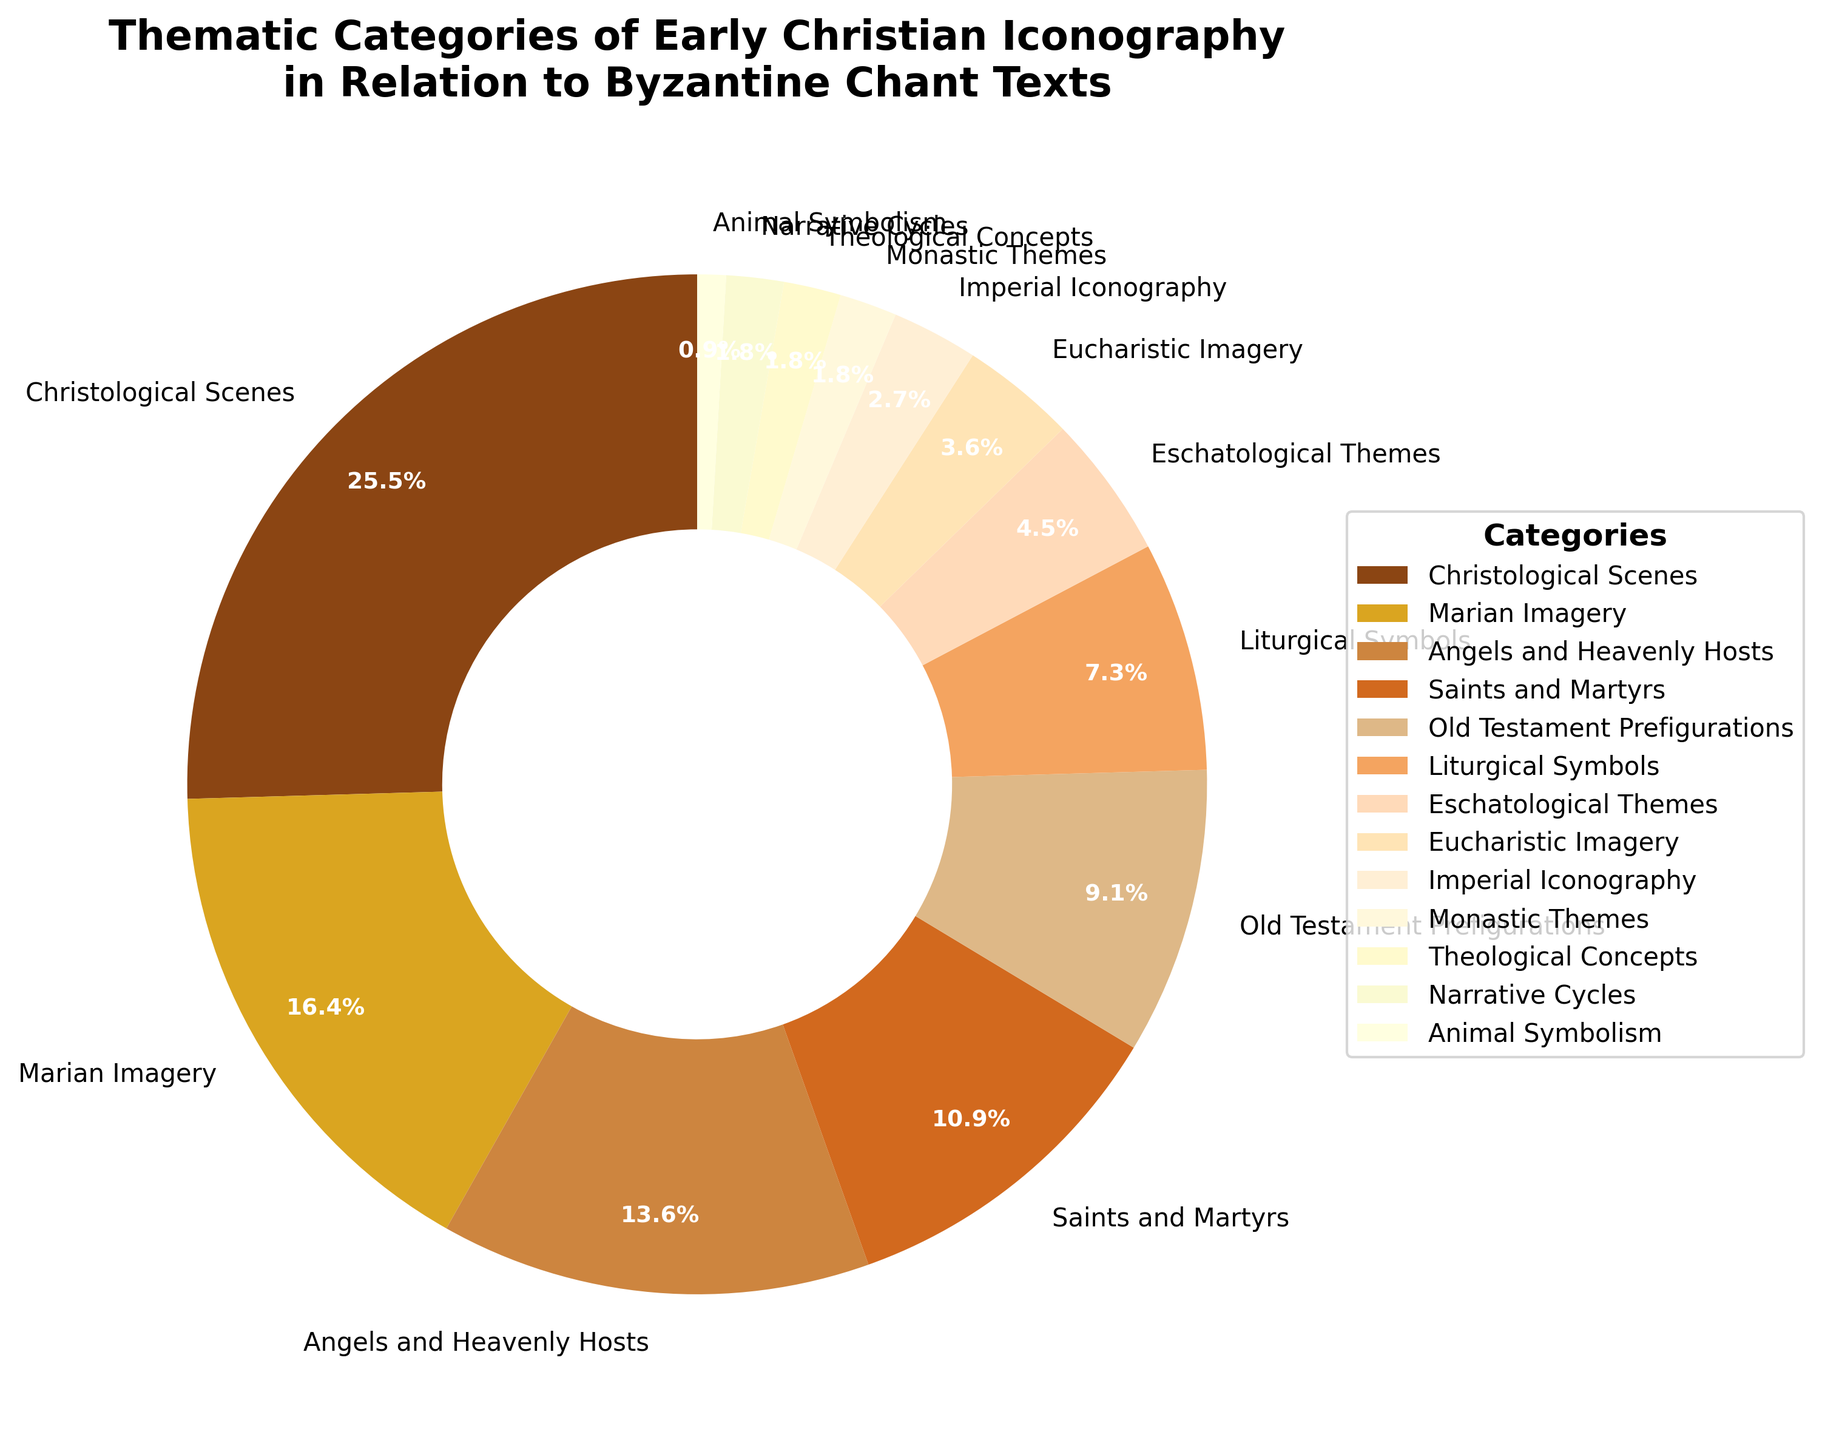What's the combined percentage of "Eschatological Themes" and "Eucharistic Imagery"? First, identify the percentage of "Eschatological Themes" which is 5%, and "Eucharistic Imagery" which is 4%. Add these two percentages together: 5% + 4% = 9%.
Answer: 9% Which category has a higher percentage, "Angels and Heavenly Hosts" or "Saints and Martyrs"? Identify the percentages for both categories: "Angels and Heavenly Hosts" is at 15% and "Saints and Martyrs" is at 12%. Since 15% is greater than 12%, "Angels and Heavenly Hosts" has a higher percentage.
Answer: Angels and Heavenly Hosts What color represents "Marian Imagery" and what percentage does it have? Look at the color assigned to "Marian Imagery" in the pie chart and note it is gold, associated with a percentage of 18%.
Answer: Gold, 18% By how much does the percentage of "Christological Scenes" exceed the percentage of "Old Testament Prefigurations"? Identify the percentages: "Christological Scenes" is 28% and "Old Testament Prefigurations" is 10%. Subtract the latter from the former: 28% - 10% = 18%.
Answer: 18% What is the total percentage of categories that have less than 4% each? Identify the categories with percentages less than 4%: "Imperial Iconography" (3%), "Monastic Themes" (2%), "Theological Concepts" (2%), "Narrative Cycles" (2%), "Animal Symbolism" (1%). Sum these percentages together: 3% + 2% + 2% + 2% + 1% = 10%.
Answer: 10% What category is represented by the darkest color and what is its percentage? Observe the darkest color on the pie chart and find which category it represents. It corresponds to "Christological Scenes" with 28%.
Answer: Christological Scenes, 28% What is the difference in the percentages of "Christological Scenes" and "Eucharistic Imagery"? Determine the percentages: "Christological Scenes" is 28% and "Eucharistic Imagery" is 4%. Calculate the difference: 28% - 4% = 24%.
Answer: 24% How does the percentage of "Liturgical Symbols" compare to the percentage of "Angels and Heavenly Hosts"? Identify the percentages: "Liturgical Symbols" is 8% and "Angels and Heavenly Hosts" is 15%. Since 8% is less than 15%, "Liturgical Symbols" has a lower percentage.
Answer: Less How much greater is the percentage of "Marian Imagery" compared to the sum of "Monastic Themes" and "Narrative Cycles"? Identify the percentages: "Marian Imagery" is 18%, "Monastic Themes" 2%, and "Narrative Cycles" 2%. First, sum "Monastic Themes" and "Narrative Cycles": 2% + 2% = 4%. Then, subtract this sum from "Marian Imagery": 18% - 4% = 14%.
Answer: 14% 